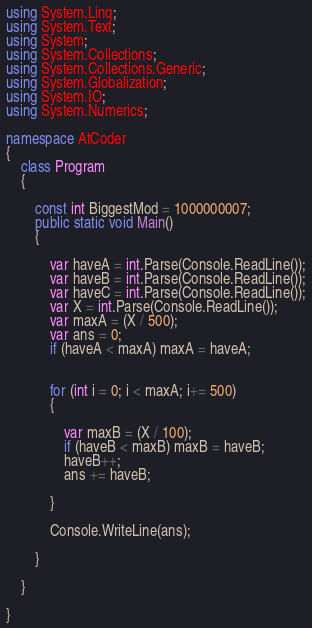<code> <loc_0><loc_0><loc_500><loc_500><_C#_>using System.Linq;
using System.Text;
using System;
using System.Collections;
using System.Collections.Generic;
using System.Globalization;
using System.IO;
using System.Numerics;

namespace AtCoder
{
    class Program
    {

        const int BiggestMod = 1000000007;
        public static void Main()
        {

            var haveA = int.Parse(Console.ReadLine());
            var haveB = int.Parse(Console.ReadLine());
            var haveC = int.Parse(Console.ReadLine());
            var X = int.Parse(Console.ReadLine());
            var maxA = (X / 500);
            var ans = 0;
            if (haveA < maxA) maxA = haveA;


            for (int i = 0; i < maxA; i+= 500)
            {

                var maxB = (X / 100);
                if (haveB < maxB) maxB = haveB;
                haveB++;
                ans += haveB;

            }

            Console.WriteLine(ans);

        }

    }

}
</code> 